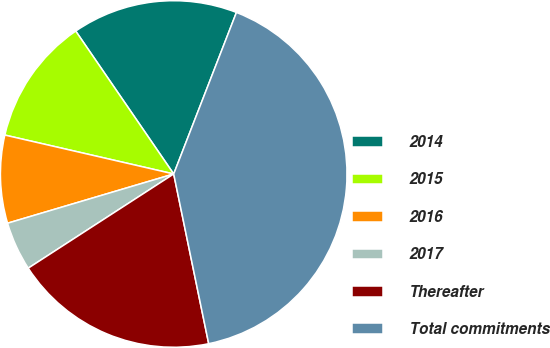Convert chart. <chart><loc_0><loc_0><loc_500><loc_500><pie_chart><fcel>2014<fcel>2015<fcel>2016<fcel>2017<fcel>Thereafter<fcel>Total commitments<nl><fcel>15.46%<fcel>11.83%<fcel>8.19%<fcel>4.56%<fcel>19.09%<fcel>40.87%<nl></chart> 